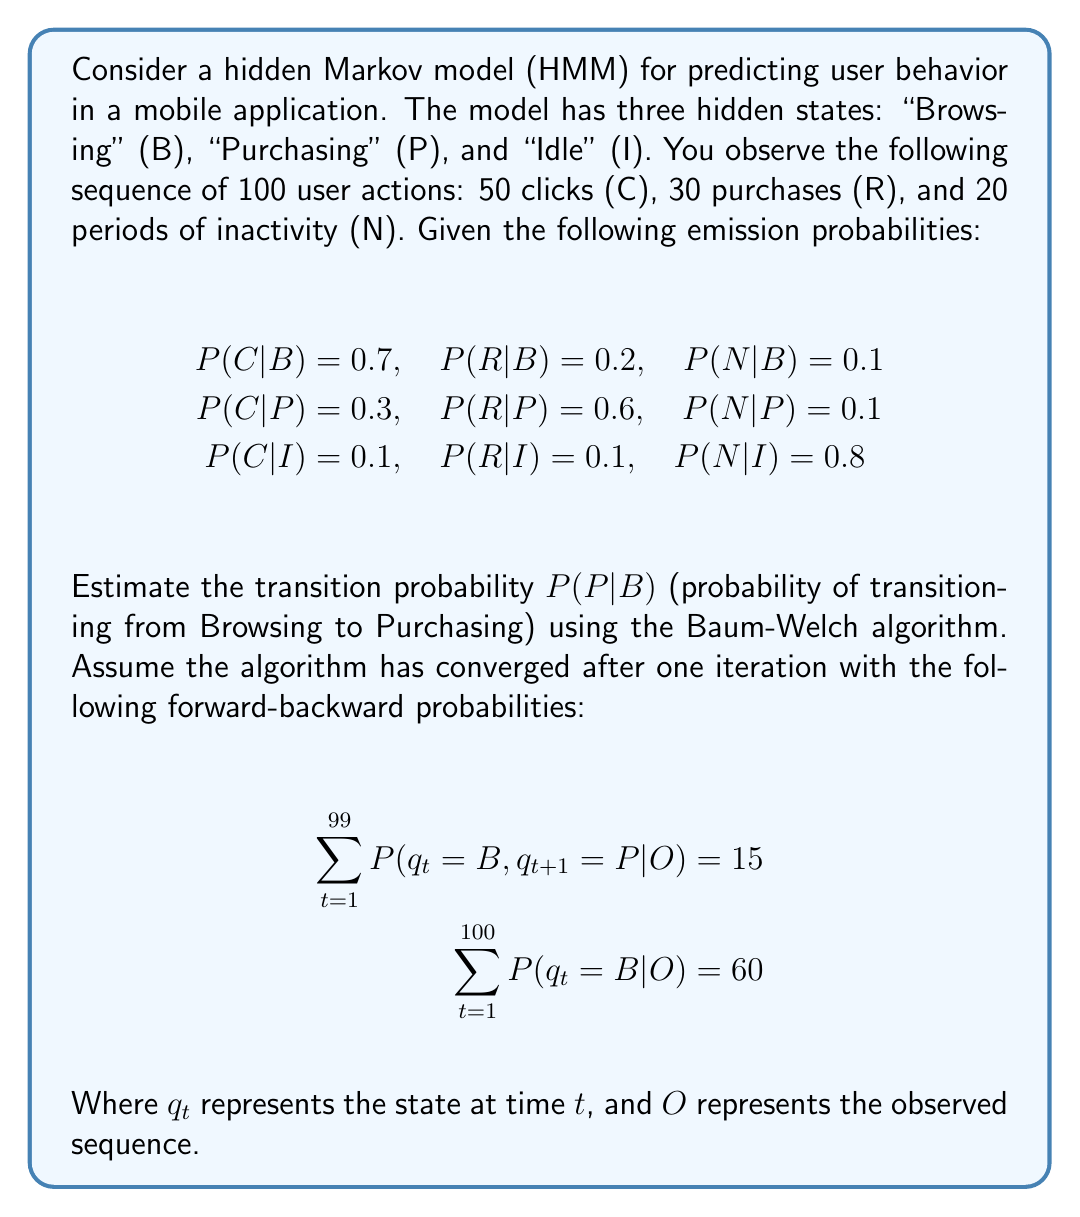What is the answer to this math problem? To estimate the transition probability $P(P|B)$ using the Baum-Welch algorithm, we'll follow these steps:

1) The Baum-Welch algorithm is an iterative method to estimate HMM parameters. After convergence, the transition probability $P(P|B)$ can be estimated using the formula:

   $$P(P|B) = \frac{\sum_{t=1}^{T-1} P(q_t = B, q_{t+1} = P | O)}{\sum_{t=1}^T P(q_t = B | O)}$$

   Where $T$ is the length of the observation sequence.

2) From the given information:
   $$\sum_{t=1}^{99} P(q_t = B, q_{t+1} = P | O) = 15$$
   $$\sum_{t=1}^{100} P(q_t = B | O) = 60$$

3) Substituting these values into the formula:

   $$P(P|B) = \frac{15}{60} = \frac{1}{4} = 0.25$$

Therefore, the estimated transition probability from the "Browsing" state to the "Purchasing" state is 0.25 or 25%.
Answer: $P(P|B) = 0.25$ 